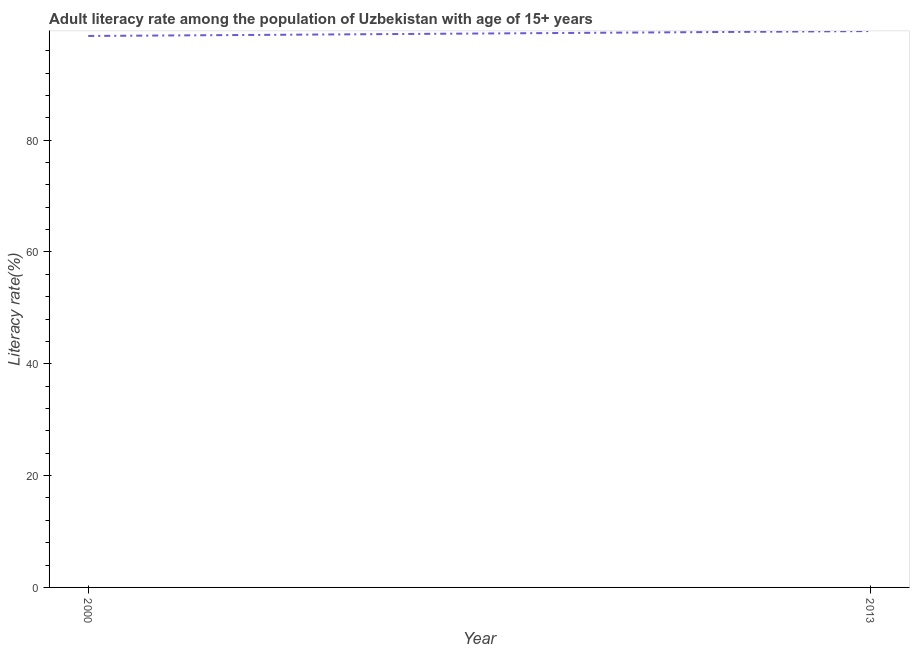What is the adult literacy rate in 2013?
Make the answer very short. 99.52. Across all years, what is the maximum adult literacy rate?
Ensure brevity in your answer.  99.52. Across all years, what is the minimum adult literacy rate?
Ensure brevity in your answer.  98.64. In which year was the adult literacy rate minimum?
Offer a terse response. 2000. What is the sum of the adult literacy rate?
Your response must be concise. 198.16. What is the difference between the adult literacy rate in 2000 and 2013?
Keep it short and to the point. -0.88. What is the average adult literacy rate per year?
Keep it short and to the point. 99.08. What is the median adult literacy rate?
Offer a terse response. 99.08. In how many years, is the adult literacy rate greater than 92 %?
Your answer should be compact. 2. What is the ratio of the adult literacy rate in 2000 to that in 2013?
Provide a short and direct response. 0.99. Does the adult literacy rate monotonically increase over the years?
Keep it short and to the point. Yes. How many years are there in the graph?
Make the answer very short. 2. What is the difference between two consecutive major ticks on the Y-axis?
Offer a very short reply. 20. Does the graph contain grids?
Your response must be concise. No. What is the title of the graph?
Offer a terse response. Adult literacy rate among the population of Uzbekistan with age of 15+ years. What is the label or title of the Y-axis?
Your answer should be compact. Literacy rate(%). What is the Literacy rate(%) in 2000?
Your answer should be compact. 98.64. What is the Literacy rate(%) of 2013?
Give a very brief answer. 99.52. What is the difference between the Literacy rate(%) in 2000 and 2013?
Give a very brief answer. -0.88. 